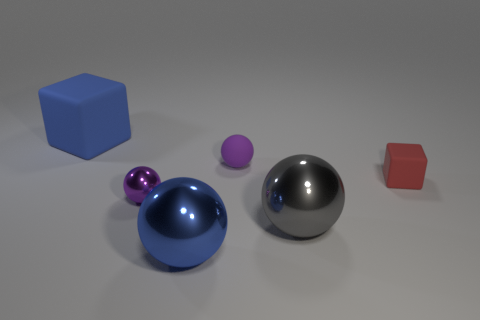Add 1 blue shiny things. How many objects exist? 7 Subtract all spheres. How many objects are left? 2 Subtract 0 yellow spheres. How many objects are left? 6 Subtract all cubes. Subtract all blocks. How many objects are left? 2 Add 1 small matte cubes. How many small matte cubes are left? 2 Add 2 small rubber blocks. How many small rubber blocks exist? 3 